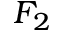Convert formula to latex. <formula><loc_0><loc_0><loc_500><loc_500>F _ { 2 }</formula> 